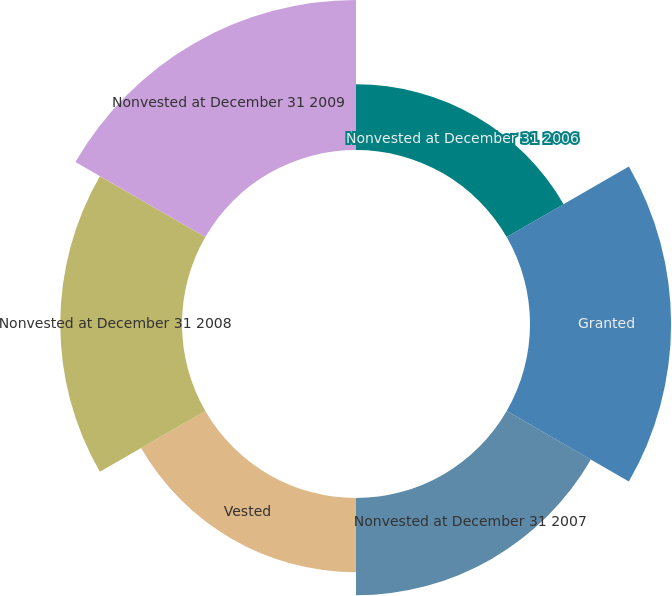Convert chart to OTSL. <chart><loc_0><loc_0><loc_500><loc_500><pie_chart><fcel>Nonvested at December 31 2006<fcel>Granted<fcel>Nonvested at December 31 2007<fcel>Vested<fcel>Nonvested at December 31 2008<fcel>Nonvested at December 31 2009<nl><fcel>10.11%<fcel>21.71%<fcel>14.96%<fcel>11.41%<fcel>18.73%<fcel>23.08%<nl></chart> 